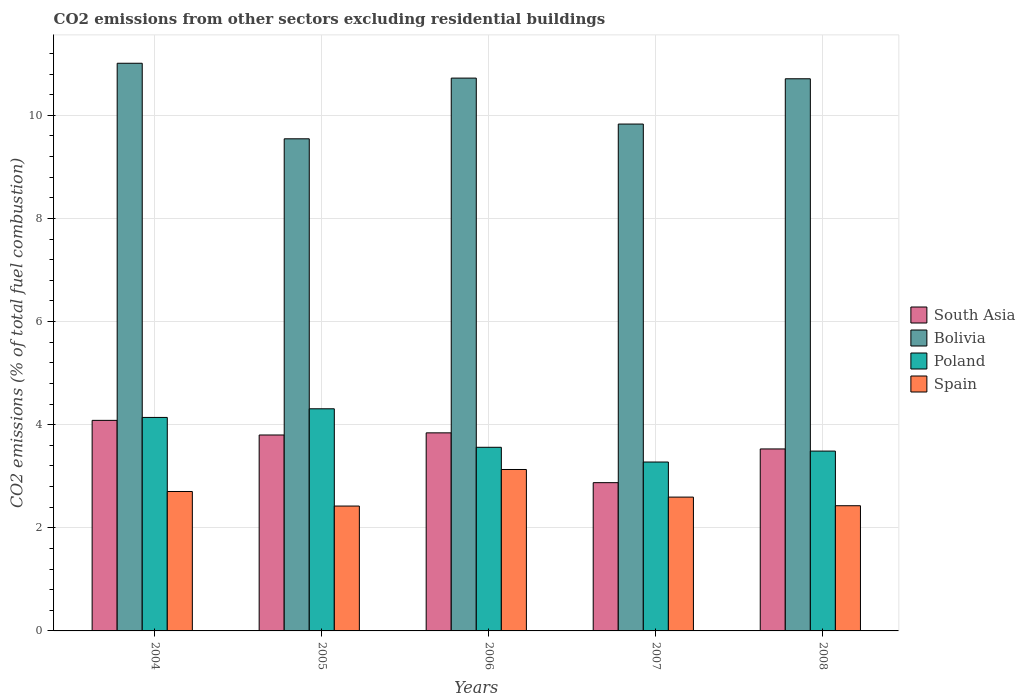How many bars are there on the 3rd tick from the right?
Make the answer very short. 4. What is the label of the 2nd group of bars from the left?
Provide a succinct answer. 2005. In how many cases, is the number of bars for a given year not equal to the number of legend labels?
Ensure brevity in your answer.  0. What is the total CO2 emitted in Bolivia in 2004?
Your answer should be very brief. 11.01. Across all years, what is the maximum total CO2 emitted in Bolivia?
Keep it short and to the point. 11.01. Across all years, what is the minimum total CO2 emitted in Spain?
Provide a succinct answer. 2.42. What is the total total CO2 emitted in Bolivia in the graph?
Offer a very short reply. 51.81. What is the difference between the total CO2 emitted in South Asia in 2005 and that in 2007?
Provide a short and direct response. 0.92. What is the difference between the total CO2 emitted in Spain in 2005 and the total CO2 emitted in Bolivia in 2004?
Give a very brief answer. -8.59. What is the average total CO2 emitted in Bolivia per year?
Offer a very short reply. 10.36. In the year 2008, what is the difference between the total CO2 emitted in Bolivia and total CO2 emitted in South Asia?
Provide a short and direct response. 7.18. What is the ratio of the total CO2 emitted in Spain in 2004 to that in 2007?
Your response must be concise. 1.04. Is the difference between the total CO2 emitted in Bolivia in 2004 and 2005 greater than the difference between the total CO2 emitted in South Asia in 2004 and 2005?
Provide a succinct answer. Yes. What is the difference between the highest and the second highest total CO2 emitted in South Asia?
Give a very brief answer. 0.24. What is the difference between the highest and the lowest total CO2 emitted in Bolivia?
Your answer should be very brief. 1.47. In how many years, is the total CO2 emitted in South Asia greater than the average total CO2 emitted in South Asia taken over all years?
Your answer should be compact. 3. Is it the case that in every year, the sum of the total CO2 emitted in South Asia and total CO2 emitted in Spain is greater than the total CO2 emitted in Bolivia?
Offer a terse response. No. How many bars are there?
Offer a terse response. 20. How many years are there in the graph?
Your answer should be very brief. 5. What is the difference between two consecutive major ticks on the Y-axis?
Provide a short and direct response. 2. Are the values on the major ticks of Y-axis written in scientific E-notation?
Your answer should be very brief. No. Does the graph contain any zero values?
Your answer should be very brief. No. Does the graph contain grids?
Ensure brevity in your answer.  Yes. Where does the legend appear in the graph?
Provide a short and direct response. Center right. How many legend labels are there?
Your answer should be compact. 4. How are the legend labels stacked?
Your answer should be very brief. Vertical. What is the title of the graph?
Ensure brevity in your answer.  CO2 emissions from other sectors excluding residential buildings. Does "Spain" appear as one of the legend labels in the graph?
Make the answer very short. Yes. What is the label or title of the X-axis?
Your response must be concise. Years. What is the label or title of the Y-axis?
Ensure brevity in your answer.  CO2 emissions (% of total fuel combustion). What is the CO2 emissions (% of total fuel combustion) in South Asia in 2004?
Provide a succinct answer. 4.08. What is the CO2 emissions (% of total fuel combustion) in Bolivia in 2004?
Your answer should be very brief. 11.01. What is the CO2 emissions (% of total fuel combustion) of Poland in 2004?
Provide a short and direct response. 4.14. What is the CO2 emissions (% of total fuel combustion) in Spain in 2004?
Your answer should be very brief. 2.7. What is the CO2 emissions (% of total fuel combustion) in South Asia in 2005?
Keep it short and to the point. 3.8. What is the CO2 emissions (% of total fuel combustion) in Bolivia in 2005?
Your response must be concise. 9.54. What is the CO2 emissions (% of total fuel combustion) in Poland in 2005?
Provide a succinct answer. 4.31. What is the CO2 emissions (% of total fuel combustion) in Spain in 2005?
Keep it short and to the point. 2.42. What is the CO2 emissions (% of total fuel combustion) in South Asia in 2006?
Keep it short and to the point. 3.84. What is the CO2 emissions (% of total fuel combustion) in Bolivia in 2006?
Your answer should be very brief. 10.72. What is the CO2 emissions (% of total fuel combustion) of Poland in 2006?
Offer a very short reply. 3.56. What is the CO2 emissions (% of total fuel combustion) in Spain in 2006?
Offer a very short reply. 3.13. What is the CO2 emissions (% of total fuel combustion) in South Asia in 2007?
Your response must be concise. 2.88. What is the CO2 emissions (% of total fuel combustion) in Bolivia in 2007?
Give a very brief answer. 9.83. What is the CO2 emissions (% of total fuel combustion) in Poland in 2007?
Ensure brevity in your answer.  3.28. What is the CO2 emissions (% of total fuel combustion) in Spain in 2007?
Provide a succinct answer. 2.6. What is the CO2 emissions (% of total fuel combustion) of South Asia in 2008?
Provide a short and direct response. 3.53. What is the CO2 emissions (% of total fuel combustion) of Bolivia in 2008?
Give a very brief answer. 10.71. What is the CO2 emissions (% of total fuel combustion) in Poland in 2008?
Your answer should be very brief. 3.49. What is the CO2 emissions (% of total fuel combustion) of Spain in 2008?
Your response must be concise. 2.43. Across all years, what is the maximum CO2 emissions (% of total fuel combustion) in South Asia?
Provide a short and direct response. 4.08. Across all years, what is the maximum CO2 emissions (% of total fuel combustion) of Bolivia?
Your response must be concise. 11.01. Across all years, what is the maximum CO2 emissions (% of total fuel combustion) of Poland?
Offer a very short reply. 4.31. Across all years, what is the maximum CO2 emissions (% of total fuel combustion) of Spain?
Offer a very short reply. 3.13. Across all years, what is the minimum CO2 emissions (% of total fuel combustion) in South Asia?
Give a very brief answer. 2.88. Across all years, what is the minimum CO2 emissions (% of total fuel combustion) in Bolivia?
Your response must be concise. 9.54. Across all years, what is the minimum CO2 emissions (% of total fuel combustion) in Poland?
Give a very brief answer. 3.28. Across all years, what is the minimum CO2 emissions (% of total fuel combustion) in Spain?
Your answer should be very brief. 2.42. What is the total CO2 emissions (% of total fuel combustion) of South Asia in the graph?
Make the answer very short. 18.13. What is the total CO2 emissions (% of total fuel combustion) in Bolivia in the graph?
Your response must be concise. 51.81. What is the total CO2 emissions (% of total fuel combustion) of Poland in the graph?
Keep it short and to the point. 18.77. What is the total CO2 emissions (% of total fuel combustion) of Spain in the graph?
Your answer should be compact. 13.28. What is the difference between the CO2 emissions (% of total fuel combustion) of South Asia in 2004 and that in 2005?
Your response must be concise. 0.28. What is the difference between the CO2 emissions (% of total fuel combustion) of Bolivia in 2004 and that in 2005?
Your answer should be compact. 1.47. What is the difference between the CO2 emissions (% of total fuel combustion) of Poland in 2004 and that in 2005?
Offer a terse response. -0.17. What is the difference between the CO2 emissions (% of total fuel combustion) of Spain in 2004 and that in 2005?
Offer a very short reply. 0.28. What is the difference between the CO2 emissions (% of total fuel combustion) in South Asia in 2004 and that in 2006?
Keep it short and to the point. 0.24. What is the difference between the CO2 emissions (% of total fuel combustion) in Bolivia in 2004 and that in 2006?
Provide a short and direct response. 0.29. What is the difference between the CO2 emissions (% of total fuel combustion) of Poland in 2004 and that in 2006?
Keep it short and to the point. 0.58. What is the difference between the CO2 emissions (% of total fuel combustion) of Spain in 2004 and that in 2006?
Your answer should be very brief. -0.43. What is the difference between the CO2 emissions (% of total fuel combustion) in South Asia in 2004 and that in 2007?
Provide a succinct answer. 1.21. What is the difference between the CO2 emissions (% of total fuel combustion) of Bolivia in 2004 and that in 2007?
Offer a terse response. 1.18. What is the difference between the CO2 emissions (% of total fuel combustion) of Poland in 2004 and that in 2007?
Offer a terse response. 0.86. What is the difference between the CO2 emissions (% of total fuel combustion) of Spain in 2004 and that in 2007?
Provide a short and direct response. 0.11. What is the difference between the CO2 emissions (% of total fuel combustion) of South Asia in 2004 and that in 2008?
Your answer should be very brief. 0.55. What is the difference between the CO2 emissions (% of total fuel combustion) in Bolivia in 2004 and that in 2008?
Give a very brief answer. 0.3. What is the difference between the CO2 emissions (% of total fuel combustion) in Poland in 2004 and that in 2008?
Ensure brevity in your answer.  0.65. What is the difference between the CO2 emissions (% of total fuel combustion) in Spain in 2004 and that in 2008?
Ensure brevity in your answer.  0.28. What is the difference between the CO2 emissions (% of total fuel combustion) in South Asia in 2005 and that in 2006?
Your answer should be compact. -0.04. What is the difference between the CO2 emissions (% of total fuel combustion) of Bolivia in 2005 and that in 2006?
Make the answer very short. -1.18. What is the difference between the CO2 emissions (% of total fuel combustion) in Poland in 2005 and that in 2006?
Provide a short and direct response. 0.75. What is the difference between the CO2 emissions (% of total fuel combustion) in Spain in 2005 and that in 2006?
Your response must be concise. -0.71. What is the difference between the CO2 emissions (% of total fuel combustion) of South Asia in 2005 and that in 2007?
Provide a short and direct response. 0.92. What is the difference between the CO2 emissions (% of total fuel combustion) of Bolivia in 2005 and that in 2007?
Ensure brevity in your answer.  -0.29. What is the difference between the CO2 emissions (% of total fuel combustion) of Poland in 2005 and that in 2007?
Your answer should be very brief. 1.03. What is the difference between the CO2 emissions (% of total fuel combustion) in Spain in 2005 and that in 2007?
Keep it short and to the point. -0.17. What is the difference between the CO2 emissions (% of total fuel combustion) in South Asia in 2005 and that in 2008?
Provide a succinct answer. 0.27. What is the difference between the CO2 emissions (% of total fuel combustion) of Bolivia in 2005 and that in 2008?
Your answer should be compact. -1.16. What is the difference between the CO2 emissions (% of total fuel combustion) in Poland in 2005 and that in 2008?
Your response must be concise. 0.82. What is the difference between the CO2 emissions (% of total fuel combustion) of Spain in 2005 and that in 2008?
Your answer should be compact. -0.01. What is the difference between the CO2 emissions (% of total fuel combustion) of South Asia in 2006 and that in 2007?
Provide a short and direct response. 0.97. What is the difference between the CO2 emissions (% of total fuel combustion) of Bolivia in 2006 and that in 2007?
Your answer should be very brief. 0.89. What is the difference between the CO2 emissions (% of total fuel combustion) of Poland in 2006 and that in 2007?
Your response must be concise. 0.29. What is the difference between the CO2 emissions (% of total fuel combustion) of Spain in 2006 and that in 2007?
Ensure brevity in your answer.  0.54. What is the difference between the CO2 emissions (% of total fuel combustion) of South Asia in 2006 and that in 2008?
Provide a short and direct response. 0.31. What is the difference between the CO2 emissions (% of total fuel combustion) in Bolivia in 2006 and that in 2008?
Provide a succinct answer. 0.01. What is the difference between the CO2 emissions (% of total fuel combustion) of Poland in 2006 and that in 2008?
Your answer should be compact. 0.07. What is the difference between the CO2 emissions (% of total fuel combustion) of Spain in 2006 and that in 2008?
Keep it short and to the point. 0.7. What is the difference between the CO2 emissions (% of total fuel combustion) in South Asia in 2007 and that in 2008?
Keep it short and to the point. -0.65. What is the difference between the CO2 emissions (% of total fuel combustion) of Bolivia in 2007 and that in 2008?
Ensure brevity in your answer.  -0.88. What is the difference between the CO2 emissions (% of total fuel combustion) in Poland in 2007 and that in 2008?
Offer a very short reply. -0.21. What is the difference between the CO2 emissions (% of total fuel combustion) in Spain in 2007 and that in 2008?
Provide a short and direct response. 0.17. What is the difference between the CO2 emissions (% of total fuel combustion) of South Asia in 2004 and the CO2 emissions (% of total fuel combustion) of Bolivia in 2005?
Provide a succinct answer. -5.46. What is the difference between the CO2 emissions (% of total fuel combustion) in South Asia in 2004 and the CO2 emissions (% of total fuel combustion) in Poland in 2005?
Provide a short and direct response. -0.22. What is the difference between the CO2 emissions (% of total fuel combustion) of South Asia in 2004 and the CO2 emissions (% of total fuel combustion) of Spain in 2005?
Your answer should be very brief. 1.66. What is the difference between the CO2 emissions (% of total fuel combustion) of Bolivia in 2004 and the CO2 emissions (% of total fuel combustion) of Poland in 2005?
Give a very brief answer. 6.7. What is the difference between the CO2 emissions (% of total fuel combustion) in Bolivia in 2004 and the CO2 emissions (% of total fuel combustion) in Spain in 2005?
Ensure brevity in your answer.  8.59. What is the difference between the CO2 emissions (% of total fuel combustion) of Poland in 2004 and the CO2 emissions (% of total fuel combustion) of Spain in 2005?
Ensure brevity in your answer.  1.72. What is the difference between the CO2 emissions (% of total fuel combustion) in South Asia in 2004 and the CO2 emissions (% of total fuel combustion) in Bolivia in 2006?
Your response must be concise. -6.64. What is the difference between the CO2 emissions (% of total fuel combustion) in South Asia in 2004 and the CO2 emissions (% of total fuel combustion) in Poland in 2006?
Your response must be concise. 0.52. What is the difference between the CO2 emissions (% of total fuel combustion) in South Asia in 2004 and the CO2 emissions (% of total fuel combustion) in Spain in 2006?
Your answer should be very brief. 0.95. What is the difference between the CO2 emissions (% of total fuel combustion) of Bolivia in 2004 and the CO2 emissions (% of total fuel combustion) of Poland in 2006?
Make the answer very short. 7.45. What is the difference between the CO2 emissions (% of total fuel combustion) in Bolivia in 2004 and the CO2 emissions (% of total fuel combustion) in Spain in 2006?
Your answer should be compact. 7.88. What is the difference between the CO2 emissions (% of total fuel combustion) of Poland in 2004 and the CO2 emissions (% of total fuel combustion) of Spain in 2006?
Give a very brief answer. 1.01. What is the difference between the CO2 emissions (% of total fuel combustion) in South Asia in 2004 and the CO2 emissions (% of total fuel combustion) in Bolivia in 2007?
Give a very brief answer. -5.75. What is the difference between the CO2 emissions (% of total fuel combustion) of South Asia in 2004 and the CO2 emissions (% of total fuel combustion) of Poland in 2007?
Your answer should be compact. 0.81. What is the difference between the CO2 emissions (% of total fuel combustion) in South Asia in 2004 and the CO2 emissions (% of total fuel combustion) in Spain in 2007?
Your response must be concise. 1.49. What is the difference between the CO2 emissions (% of total fuel combustion) of Bolivia in 2004 and the CO2 emissions (% of total fuel combustion) of Poland in 2007?
Your answer should be very brief. 7.73. What is the difference between the CO2 emissions (% of total fuel combustion) of Bolivia in 2004 and the CO2 emissions (% of total fuel combustion) of Spain in 2007?
Give a very brief answer. 8.41. What is the difference between the CO2 emissions (% of total fuel combustion) in Poland in 2004 and the CO2 emissions (% of total fuel combustion) in Spain in 2007?
Keep it short and to the point. 1.55. What is the difference between the CO2 emissions (% of total fuel combustion) of South Asia in 2004 and the CO2 emissions (% of total fuel combustion) of Bolivia in 2008?
Provide a short and direct response. -6.62. What is the difference between the CO2 emissions (% of total fuel combustion) of South Asia in 2004 and the CO2 emissions (% of total fuel combustion) of Poland in 2008?
Offer a very short reply. 0.6. What is the difference between the CO2 emissions (% of total fuel combustion) of South Asia in 2004 and the CO2 emissions (% of total fuel combustion) of Spain in 2008?
Your response must be concise. 1.66. What is the difference between the CO2 emissions (% of total fuel combustion) in Bolivia in 2004 and the CO2 emissions (% of total fuel combustion) in Poland in 2008?
Provide a succinct answer. 7.52. What is the difference between the CO2 emissions (% of total fuel combustion) in Bolivia in 2004 and the CO2 emissions (% of total fuel combustion) in Spain in 2008?
Provide a short and direct response. 8.58. What is the difference between the CO2 emissions (% of total fuel combustion) in Poland in 2004 and the CO2 emissions (% of total fuel combustion) in Spain in 2008?
Make the answer very short. 1.71. What is the difference between the CO2 emissions (% of total fuel combustion) in South Asia in 2005 and the CO2 emissions (% of total fuel combustion) in Bolivia in 2006?
Provide a short and direct response. -6.92. What is the difference between the CO2 emissions (% of total fuel combustion) of South Asia in 2005 and the CO2 emissions (% of total fuel combustion) of Poland in 2006?
Offer a very short reply. 0.24. What is the difference between the CO2 emissions (% of total fuel combustion) in South Asia in 2005 and the CO2 emissions (% of total fuel combustion) in Spain in 2006?
Your answer should be very brief. 0.67. What is the difference between the CO2 emissions (% of total fuel combustion) of Bolivia in 2005 and the CO2 emissions (% of total fuel combustion) of Poland in 2006?
Your answer should be compact. 5.98. What is the difference between the CO2 emissions (% of total fuel combustion) of Bolivia in 2005 and the CO2 emissions (% of total fuel combustion) of Spain in 2006?
Your answer should be compact. 6.41. What is the difference between the CO2 emissions (% of total fuel combustion) of Poland in 2005 and the CO2 emissions (% of total fuel combustion) of Spain in 2006?
Make the answer very short. 1.18. What is the difference between the CO2 emissions (% of total fuel combustion) in South Asia in 2005 and the CO2 emissions (% of total fuel combustion) in Bolivia in 2007?
Make the answer very short. -6.03. What is the difference between the CO2 emissions (% of total fuel combustion) of South Asia in 2005 and the CO2 emissions (% of total fuel combustion) of Poland in 2007?
Ensure brevity in your answer.  0.52. What is the difference between the CO2 emissions (% of total fuel combustion) of South Asia in 2005 and the CO2 emissions (% of total fuel combustion) of Spain in 2007?
Provide a succinct answer. 1.2. What is the difference between the CO2 emissions (% of total fuel combustion) in Bolivia in 2005 and the CO2 emissions (% of total fuel combustion) in Poland in 2007?
Your answer should be compact. 6.27. What is the difference between the CO2 emissions (% of total fuel combustion) in Bolivia in 2005 and the CO2 emissions (% of total fuel combustion) in Spain in 2007?
Your answer should be compact. 6.95. What is the difference between the CO2 emissions (% of total fuel combustion) in Poland in 2005 and the CO2 emissions (% of total fuel combustion) in Spain in 2007?
Ensure brevity in your answer.  1.71. What is the difference between the CO2 emissions (% of total fuel combustion) of South Asia in 2005 and the CO2 emissions (% of total fuel combustion) of Bolivia in 2008?
Ensure brevity in your answer.  -6.91. What is the difference between the CO2 emissions (% of total fuel combustion) in South Asia in 2005 and the CO2 emissions (% of total fuel combustion) in Poland in 2008?
Offer a terse response. 0.31. What is the difference between the CO2 emissions (% of total fuel combustion) in South Asia in 2005 and the CO2 emissions (% of total fuel combustion) in Spain in 2008?
Keep it short and to the point. 1.37. What is the difference between the CO2 emissions (% of total fuel combustion) of Bolivia in 2005 and the CO2 emissions (% of total fuel combustion) of Poland in 2008?
Your answer should be compact. 6.06. What is the difference between the CO2 emissions (% of total fuel combustion) in Bolivia in 2005 and the CO2 emissions (% of total fuel combustion) in Spain in 2008?
Your response must be concise. 7.12. What is the difference between the CO2 emissions (% of total fuel combustion) in Poland in 2005 and the CO2 emissions (% of total fuel combustion) in Spain in 2008?
Your answer should be compact. 1.88. What is the difference between the CO2 emissions (% of total fuel combustion) in South Asia in 2006 and the CO2 emissions (% of total fuel combustion) in Bolivia in 2007?
Make the answer very short. -5.99. What is the difference between the CO2 emissions (% of total fuel combustion) in South Asia in 2006 and the CO2 emissions (% of total fuel combustion) in Poland in 2007?
Make the answer very short. 0.57. What is the difference between the CO2 emissions (% of total fuel combustion) of South Asia in 2006 and the CO2 emissions (% of total fuel combustion) of Spain in 2007?
Provide a short and direct response. 1.25. What is the difference between the CO2 emissions (% of total fuel combustion) of Bolivia in 2006 and the CO2 emissions (% of total fuel combustion) of Poland in 2007?
Offer a very short reply. 7.45. What is the difference between the CO2 emissions (% of total fuel combustion) of Bolivia in 2006 and the CO2 emissions (% of total fuel combustion) of Spain in 2007?
Provide a succinct answer. 8.13. What is the difference between the CO2 emissions (% of total fuel combustion) of Poland in 2006 and the CO2 emissions (% of total fuel combustion) of Spain in 2007?
Your answer should be very brief. 0.97. What is the difference between the CO2 emissions (% of total fuel combustion) in South Asia in 2006 and the CO2 emissions (% of total fuel combustion) in Bolivia in 2008?
Your response must be concise. -6.87. What is the difference between the CO2 emissions (% of total fuel combustion) in South Asia in 2006 and the CO2 emissions (% of total fuel combustion) in Poland in 2008?
Provide a short and direct response. 0.35. What is the difference between the CO2 emissions (% of total fuel combustion) of South Asia in 2006 and the CO2 emissions (% of total fuel combustion) of Spain in 2008?
Keep it short and to the point. 1.41. What is the difference between the CO2 emissions (% of total fuel combustion) of Bolivia in 2006 and the CO2 emissions (% of total fuel combustion) of Poland in 2008?
Offer a very short reply. 7.23. What is the difference between the CO2 emissions (% of total fuel combustion) in Bolivia in 2006 and the CO2 emissions (% of total fuel combustion) in Spain in 2008?
Make the answer very short. 8.29. What is the difference between the CO2 emissions (% of total fuel combustion) in Poland in 2006 and the CO2 emissions (% of total fuel combustion) in Spain in 2008?
Ensure brevity in your answer.  1.13. What is the difference between the CO2 emissions (% of total fuel combustion) in South Asia in 2007 and the CO2 emissions (% of total fuel combustion) in Bolivia in 2008?
Offer a very short reply. -7.83. What is the difference between the CO2 emissions (% of total fuel combustion) in South Asia in 2007 and the CO2 emissions (% of total fuel combustion) in Poland in 2008?
Give a very brief answer. -0.61. What is the difference between the CO2 emissions (% of total fuel combustion) in South Asia in 2007 and the CO2 emissions (% of total fuel combustion) in Spain in 2008?
Keep it short and to the point. 0.45. What is the difference between the CO2 emissions (% of total fuel combustion) of Bolivia in 2007 and the CO2 emissions (% of total fuel combustion) of Poland in 2008?
Ensure brevity in your answer.  6.34. What is the difference between the CO2 emissions (% of total fuel combustion) of Bolivia in 2007 and the CO2 emissions (% of total fuel combustion) of Spain in 2008?
Give a very brief answer. 7.4. What is the difference between the CO2 emissions (% of total fuel combustion) of Poland in 2007 and the CO2 emissions (% of total fuel combustion) of Spain in 2008?
Offer a very short reply. 0.85. What is the average CO2 emissions (% of total fuel combustion) of South Asia per year?
Ensure brevity in your answer.  3.63. What is the average CO2 emissions (% of total fuel combustion) of Bolivia per year?
Provide a succinct answer. 10.36. What is the average CO2 emissions (% of total fuel combustion) in Poland per year?
Offer a terse response. 3.75. What is the average CO2 emissions (% of total fuel combustion) of Spain per year?
Offer a very short reply. 2.66. In the year 2004, what is the difference between the CO2 emissions (% of total fuel combustion) in South Asia and CO2 emissions (% of total fuel combustion) in Bolivia?
Make the answer very short. -6.93. In the year 2004, what is the difference between the CO2 emissions (% of total fuel combustion) in South Asia and CO2 emissions (% of total fuel combustion) in Poland?
Make the answer very short. -0.06. In the year 2004, what is the difference between the CO2 emissions (% of total fuel combustion) in South Asia and CO2 emissions (% of total fuel combustion) in Spain?
Keep it short and to the point. 1.38. In the year 2004, what is the difference between the CO2 emissions (% of total fuel combustion) of Bolivia and CO2 emissions (% of total fuel combustion) of Poland?
Ensure brevity in your answer.  6.87. In the year 2004, what is the difference between the CO2 emissions (% of total fuel combustion) of Bolivia and CO2 emissions (% of total fuel combustion) of Spain?
Make the answer very short. 8.31. In the year 2004, what is the difference between the CO2 emissions (% of total fuel combustion) of Poland and CO2 emissions (% of total fuel combustion) of Spain?
Your answer should be very brief. 1.44. In the year 2005, what is the difference between the CO2 emissions (% of total fuel combustion) in South Asia and CO2 emissions (% of total fuel combustion) in Bolivia?
Offer a terse response. -5.74. In the year 2005, what is the difference between the CO2 emissions (% of total fuel combustion) of South Asia and CO2 emissions (% of total fuel combustion) of Poland?
Provide a short and direct response. -0.51. In the year 2005, what is the difference between the CO2 emissions (% of total fuel combustion) of South Asia and CO2 emissions (% of total fuel combustion) of Spain?
Keep it short and to the point. 1.38. In the year 2005, what is the difference between the CO2 emissions (% of total fuel combustion) of Bolivia and CO2 emissions (% of total fuel combustion) of Poland?
Provide a succinct answer. 5.24. In the year 2005, what is the difference between the CO2 emissions (% of total fuel combustion) in Bolivia and CO2 emissions (% of total fuel combustion) in Spain?
Offer a terse response. 7.12. In the year 2005, what is the difference between the CO2 emissions (% of total fuel combustion) of Poland and CO2 emissions (% of total fuel combustion) of Spain?
Give a very brief answer. 1.89. In the year 2006, what is the difference between the CO2 emissions (% of total fuel combustion) of South Asia and CO2 emissions (% of total fuel combustion) of Bolivia?
Your response must be concise. -6.88. In the year 2006, what is the difference between the CO2 emissions (% of total fuel combustion) of South Asia and CO2 emissions (% of total fuel combustion) of Poland?
Give a very brief answer. 0.28. In the year 2006, what is the difference between the CO2 emissions (% of total fuel combustion) of South Asia and CO2 emissions (% of total fuel combustion) of Spain?
Make the answer very short. 0.71. In the year 2006, what is the difference between the CO2 emissions (% of total fuel combustion) of Bolivia and CO2 emissions (% of total fuel combustion) of Poland?
Ensure brevity in your answer.  7.16. In the year 2006, what is the difference between the CO2 emissions (% of total fuel combustion) in Bolivia and CO2 emissions (% of total fuel combustion) in Spain?
Provide a succinct answer. 7.59. In the year 2006, what is the difference between the CO2 emissions (% of total fuel combustion) of Poland and CO2 emissions (% of total fuel combustion) of Spain?
Offer a very short reply. 0.43. In the year 2007, what is the difference between the CO2 emissions (% of total fuel combustion) of South Asia and CO2 emissions (% of total fuel combustion) of Bolivia?
Your answer should be very brief. -6.95. In the year 2007, what is the difference between the CO2 emissions (% of total fuel combustion) of South Asia and CO2 emissions (% of total fuel combustion) of Poland?
Your answer should be compact. -0.4. In the year 2007, what is the difference between the CO2 emissions (% of total fuel combustion) of South Asia and CO2 emissions (% of total fuel combustion) of Spain?
Your response must be concise. 0.28. In the year 2007, what is the difference between the CO2 emissions (% of total fuel combustion) of Bolivia and CO2 emissions (% of total fuel combustion) of Poland?
Ensure brevity in your answer.  6.55. In the year 2007, what is the difference between the CO2 emissions (% of total fuel combustion) of Bolivia and CO2 emissions (% of total fuel combustion) of Spain?
Keep it short and to the point. 7.24. In the year 2007, what is the difference between the CO2 emissions (% of total fuel combustion) of Poland and CO2 emissions (% of total fuel combustion) of Spain?
Offer a very short reply. 0.68. In the year 2008, what is the difference between the CO2 emissions (% of total fuel combustion) in South Asia and CO2 emissions (% of total fuel combustion) in Bolivia?
Offer a terse response. -7.18. In the year 2008, what is the difference between the CO2 emissions (% of total fuel combustion) in South Asia and CO2 emissions (% of total fuel combustion) in Poland?
Your answer should be compact. 0.04. In the year 2008, what is the difference between the CO2 emissions (% of total fuel combustion) of South Asia and CO2 emissions (% of total fuel combustion) of Spain?
Your response must be concise. 1.1. In the year 2008, what is the difference between the CO2 emissions (% of total fuel combustion) of Bolivia and CO2 emissions (% of total fuel combustion) of Poland?
Offer a very short reply. 7.22. In the year 2008, what is the difference between the CO2 emissions (% of total fuel combustion) in Bolivia and CO2 emissions (% of total fuel combustion) in Spain?
Your answer should be very brief. 8.28. In the year 2008, what is the difference between the CO2 emissions (% of total fuel combustion) of Poland and CO2 emissions (% of total fuel combustion) of Spain?
Offer a terse response. 1.06. What is the ratio of the CO2 emissions (% of total fuel combustion) of South Asia in 2004 to that in 2005?
Offer a very short reply. 1.07. What is the ratio of the CO2 emissions (% of total fuel combustion) of Bolivia in 2004 to that in 2005?
Your answer should be very brief. 1.15. What is the ratio of the CO2 emissions (% of total fuel combustion) in Poland in 2004 to that in 2005?
Offer a terse response. 0.96. What is the ratio of the CO2 emissions (% of total fuel combustion) of Spain in 2004 to that in 2005?
Ensure brevity in your answer.  1.12. What is the ratio of the CO2 emissions (% of total fuel combustion) of South Asia in 2004 to that in 2006?
Ensure brevity in your answer.  1.06. What is the ratio of the CO2 emissions (% of total fuel combustion) in Bolivia in 2004 to that in 2006?
Provide a short and direct response. 1.03. What is the ratio of the CO2 emissions (% of total fuel combustion) of Poland in 2004 to that in 2006?
Offer a very short reply. 1.16. What is the ratio of the CO2 emissions (% of total fuel combustion) of Spain in 2004 to that in 2006?
Offer a very short reply. 0.86. What is the ratio of the CO2 emissions (% of total fuel combustion) in South Asia in 2004 to that in 2007?
Your response must be concise. 1.42. What is the ratio of the CO2 emissions (% of total fuel combustion) in Bolivia in 2004 to that in 2007?
Your answer should be very brief. 1.12. What is the ratio of the CO2 emissions (% of total fuel combustion) in Poland in 2004 to that in 2007?
Keep it short and to the point. 1.26. What is the ratio of the CO2 emissions (% of total fuel combustion) in Spain in 2004 to that in 2007?
Your answer should be very brief. 1.04. What is the ratio of the CO2 emissions (% of total fuel combustion) in South Asia in 2004 to that in 2008?
Keep it short and to the point. 1.16. What is the ratio of the CO2 emissions (% of total fuel combustion) of Bolivia in 2004 to that in 2008?
Your answer should be compact. 1.03. What is the ratio of the CO2 emissions (% of total fuel combustion) of Poland in 2004 to that in 2008?
Your answer should be compact. 1.19. What is the ratio of the CO2 emissions (% of total fuel combustion) of Spain in 2004 to that in 2008?
Ensure brevity in your answer.  1.11. What is the ratio of the CO2 emissions (% of total fuel combustion) of South Asia in 2005 to that in 2006?
Offer a terse response. 0.99. What is the ratio of the CO2 emissions (% of total fuel combustion) in Bolivia in 2005 to that in 2006?
Your response must be concise. 0.89. What is the ratio of the CO2 emissions (% of total fuel combustion) in Poland in 2005 to that in 2006?
Keep it short and to the point. 1.21. What is the ratio of the CO2 emissions (% of total fuel combustion) in Spain in 2005 to that in 2006?
Keep it short and to the point. 0.77. What is the ratio of the CO2 emissions (% of total fuel combustion) in South Asia in 2005 to that in 2007?
Your answer should be compact. 1.32. What is the ratio of the CO2 emissions (% of total fuel combustion) in Bolivia in 2005 to that in 2007?
Provide a short and direct response. 0.97. What is the ratio of the CO2 emissions (% of total fuel combustion) in Poland in 2005 to that in 2007?
Your answer should be very brief. 1.32. What is the ratio of the CO2 emissions (% of total fuel combustion) of Spain in 2005 to that in 2007?
Your answer should be compact. 0.93. What is the ratio of the CO2 emissions (% of total fuel combustion) of South Asia in 2005 to that in 2008?
Make the answer very short. 1.08. What is the ratio of the CO2 emissions (% of total fuel combustion) of Bolivia in 2005 to that in 2008?
Make the answer very short. 0.89. What is the ratio of the CO2 emissions (% of total fuel combustion) of Poland in 2005 to that in 2008?
Provide a short and direct response. 1.24. What is the ratio of the CO2 emissions (% of total fuel combustion) of Spain in 2005 to that in 2008?
Your answer should be compact. 1. What is the ratio of the CO2 emissions (% of total fuel combustion) in South Asia in 2006 to that in 2007?
Offer a very short reply. 1.34. What is the ratio of the CO2 emissions (% of total fuel combustion) in Bolivia in 2006 to that in 2007?
Offer a very short reply. 1.09. What is the ratio of the CO2 emissions (% of total fuel combustion) of Poland in 2006 to that in 2007?
Keep it short and to the point. 1.09. What is the ratio of the CO2 emissions (% of total fuel combustion) in Spain in 2006 to that in 2007?
Ensure brevity in your answer.  1.21. What is the ratio of the CO2 emissions (% of total fuel combustion) of South Asia in 2006 to that in 2008?
Ensure brevity in your answer.  1.09. What is the ratio of the CO2 emissions (% of total fuel combustion) in Poland in 2006 to that in 2008?
Your answer should be compact. 1.02. What is the ratio of the CO2 emissions (% of total fuel combustion) of Spain in 2006 to that in 2008?
Your answer should be very brief. 1.29. What is the ratio of the CO2 emissions (% of total fuel combustion) in South Asia in 2007 to that in 2008?
Provide a succinct answer. 0.81. What is the ratio of the CO2 emissions (% of total fuel combustion) of Bolivia in 2007 to that in 2008?
Ensure brevity in your answer.  0.92. What is the ratio of the CO2 emissions (% of total fuel combustion) of Poland in 2007 to that in 2008?
Your answer should be very brief. 0.94. What is the ratio of the CO2 emissions (% of total fuel combustion) in Spain in 2007 to that in 2008?
Give a very brief answer. 1.07. What is the difference between the highest and the second highest CO2 emissions (% of total fuel combustion) of South Asia?
Offer a very short reply. 0.24. What is the difference between the highest and the second highest CO2 emissions (% of total fuel combustion) in Bolivia?
Your answer should be very brief. 0.29. What is the difference between the highest and the second highest CO2 emissions (% of total fuel combustion) of Poland?
Offer a very short reply. 0.17. What is the difference between the highest and the second highest CO2 emissions (% of total fuel combustion) in Spain?
Provide a short and direct response. 0.43. What is the difference between the highest and the lowest CO2 emissions (% of total fuel combustion) in South Asia?
Give a very brief answer. 1.21. What is the difference between the highest and the lowest CO2 emissions (% of total fuel combustion) of Bolivia?
Offer a terse response. 1.47. What is the difference between the highest and the lowest CO2 emissions (% of total fuel combustion) of Poland?
Your response must be concise. 1.03. What is the difference between the highest and the lowest CO2 emissions (% of total fuel combustion) in Spain?
Provide a short and direct response. 0.71. 